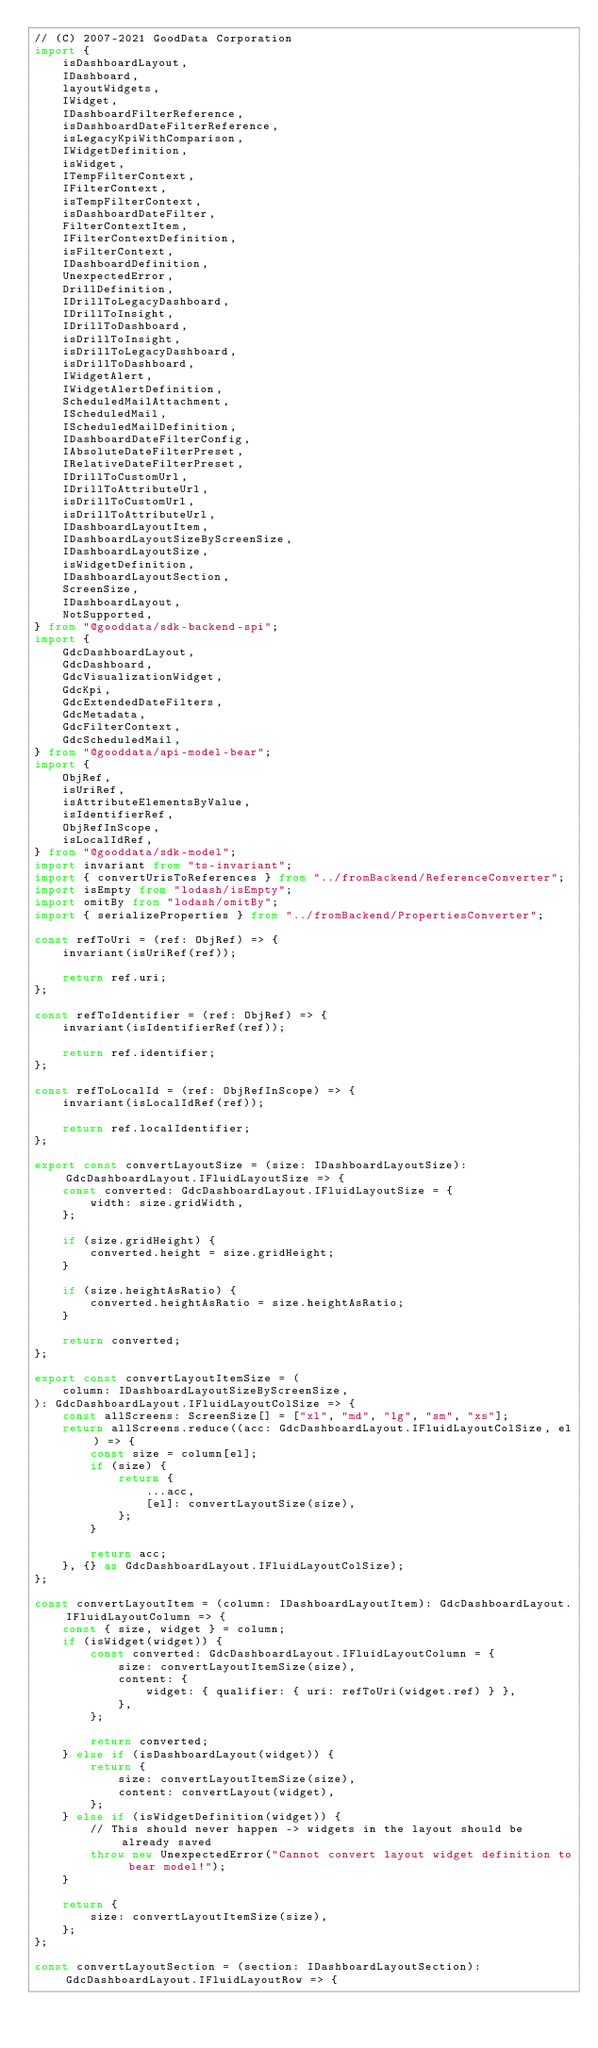<code> <loc_0><loc_0><loc_500><loc_500><_TypeScript_>// (C) 2007-2021 GoodData Corporation
import {
    isDashboardLayout,
    IDashboard,
    layoutWidgets,
    IWidget,
    IDashboardFilterReference,
    isDashboardDateFilterReference,
    isLegacyKpiWithComparison,
    IWidgetDefinition,
    isWidget,
    ITempFilterContext,
    IFilterContext,
    isTempFilterContext,
    isDashboardDateFilter,
    FilterContextItem,
    IFilterContextDefinition,
    isFilterContext,
    IDashboardDefinition,
    UnexpectedError,
    DrillDefinition,
    IDrillToLegacyDashboard,
    IDrillToInsight,
    IDrillToDashboard,
    isDrillToInsight,
    isDrillToLegacyDashboard,
    isDrillToDashboard,
    IWidgetAlert,
    IWidgetAlertDefinition,
    ScheduledMailAttachment,
    IScheduledMail,
    IScheduledMailDefinition,
    IDashboardDateFilterConfig,
    IAbsoluteDateFilterPreset,
    IRelativeDateFilterPreset,
    IDrillToCustomUrl,
    IDrillToAttributeUrl,
    isDrillToCustomUrl,
    isDrillToAttributeUrl,
    IDashboardLayoutItem,
    IDashboardLayoutSizeByScreenSize,
    IDashboardLayoutSize,
    isWidgetDefinition,
    IDashboardLayoutSection,
    ScreenSize,
    IDashboardLayout,
    NotSupported,
} from "@gooddata/sdk-backend-spi";
import {
    GdcDashboardLayout,
    GdcDashboard,
    GdcVisualizationWidget,
    GdcKpi,
    GdcExtendedDateFilters,
    GdcMetadata,
    GdcFilterContext,
    GdcScheduledMail,
} from "@gooddata/api-model-bear";
import {
    ObjRef,
    isUriRef,
    isAttributeElementsByValue,
    isIdentifierRef,
    ObjRefInScope,
    isLocalIdRef,
} from "@gooddata/sdk-model";
import invariant from "ts-invariant";
import { convertUrisToReferences } from "../fromBackend/ReferenceConverter";
import isEmpty from "lodash/isEmpty";
import omitBy from "lodash/omitBy";
import { serializeProperties } from "../fromBackend/PropertiesConverter";

const refToUri = (ref: ObjRef) => {
    invariant(isUriRef(ref));

    return ref.uri;
};

const refToIdentifier = (ref: ObjRef) => {
    invariant(isIdentifierRef(ref));

    return ref.identifier;
};

const refToLocalId = (ref: ObjRefInScope) => {
    invariant(isLocalIdRef(ref));

    return ref.localIdentifier;
};

export const convertLayoutSize = (size: IDashboardLayoutSize): GdcDashboardLayout.IFluidLayoutSize => {
    const converted: GdcDashboardLayout.IFluidLayoutSize = {
        width: size.gridWidth,
    };

    if (size.gridHeight) {
        converted.height = size.gridHeight;
    }

    if (size.heightAsRatio) {
        converted.heightAsRatio = size.heightAsRatio;
    }

    return converted;
};

export const convertLayoutItemSize = (
    column: IDashboardLayoutSizeByScreenSize,
): GdcDashboardLayout.IFluidLayoutColSize => {
    const allScreens: ScreenSize[] = ["xl", "md", "lg", "sm", "xs"];
    return allScreens.reduce((acc: GdcDashboardLayout.IFluidLayoutColSize, el) => {
        const size = column[el];
        if (size) {
            return {
                ...acc,
                [el]: convertLayoutSize(size),
            };
        }

        return acc;
    }, {} as GdcDashboardLayout.IFluidLayoutColSize);
};

const convertLayoutItem = (column: IDashboardLayoutItem): GdcDashboardLayout.IFluidLayoutColumn => {
    const { size, widget } = column;
    if (isWidget(widget)) {
        const converted: GdcDashboardLayout.IFluidLayoutColumn = {
            size: convertLayoutItemSize(size),
            content: {
                widget: { qualifier: { uri: refToUri(widget.ref) } },
            },
        };

        return converted;
    } else if (isDashboardLayout(widget)) {
        return {
            size: convertLayoutItemSize(size),
            content: convertLayout(widget),
        };
    } else if (isWidgetDefinition(widget)) {
        // This should never happen -> widgets in the layout should be already saved
        throw new UnexpectedError("Cannot convert layout widget definition to bear model!");
    }

    return {
        size: convertLayoutItemSize(size),
    };
};

const convertLayoutSection = (section: IDashboardLayoutSection): GdcDashboardLayout.IFluidLayoutRow => {</code> 